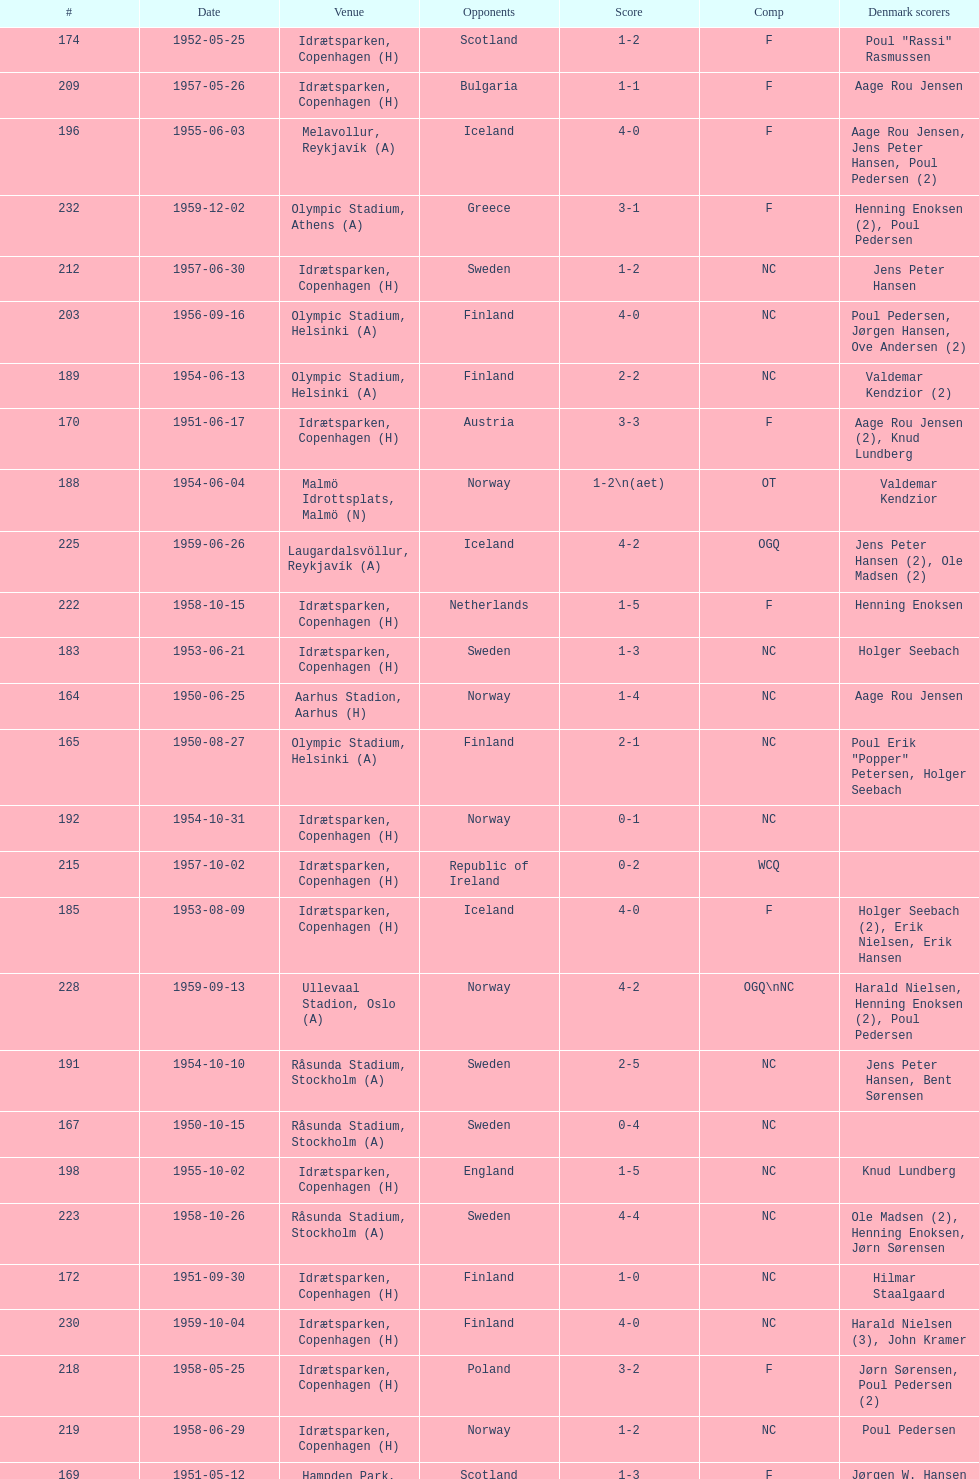What was the difference in score between the two teams in the last game? 1. 